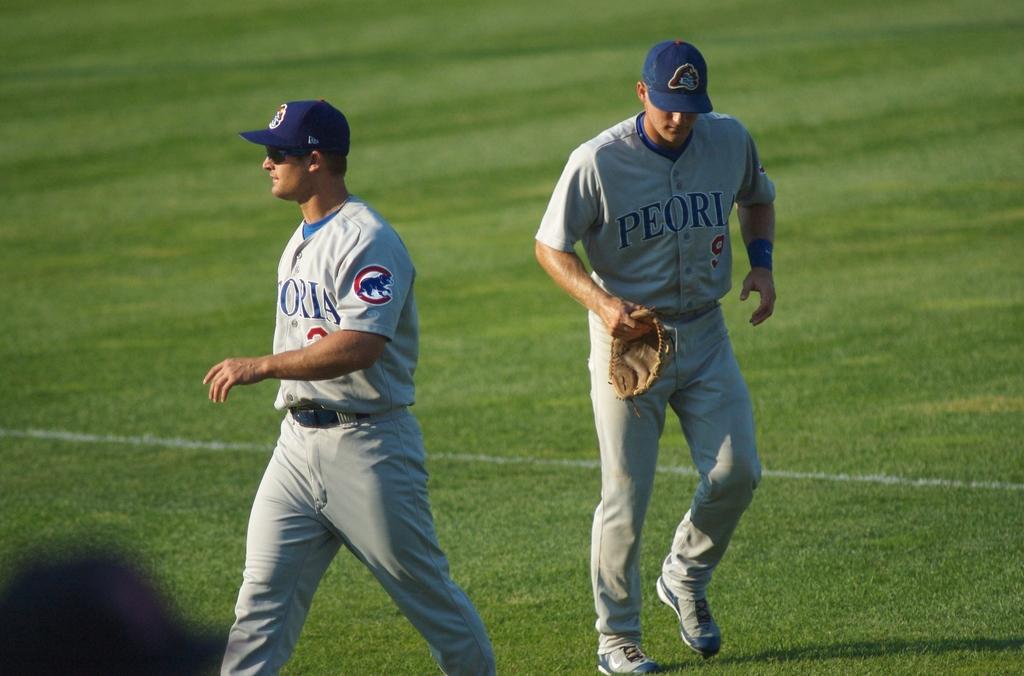What team is this?
Ensure brevity in your answer.  Peoria. Is peoria in illinois?
Make the answer very short. Answering does not require reading text in the image. 